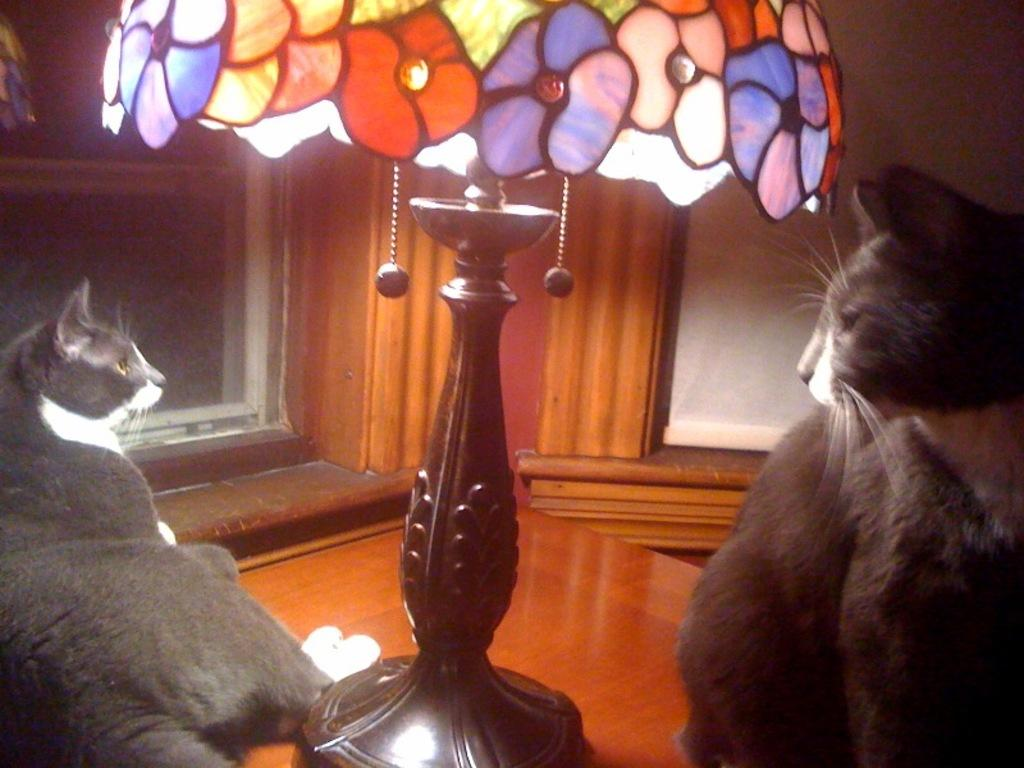How many cats are in the image? There are two cats in the image. Where are the cats located on the table? The cats are sitting on a wooden table, and they are in the middle of the table. What else can be seen on the table? There is a lamp on the table. What is visible in the background of the image? There is a wooden wall in the background, and there is a window in the wooden wall. What type of feast is being prepared on the table in the image? There is no feast being prepared on the table in the image; it only shows two cats sitting on a wooden table with a lamp. What is the reaction of the cats to the lamp on the table? The cats' reaction to the lamp cannot be determined from the image, as they are not interacting with it. 